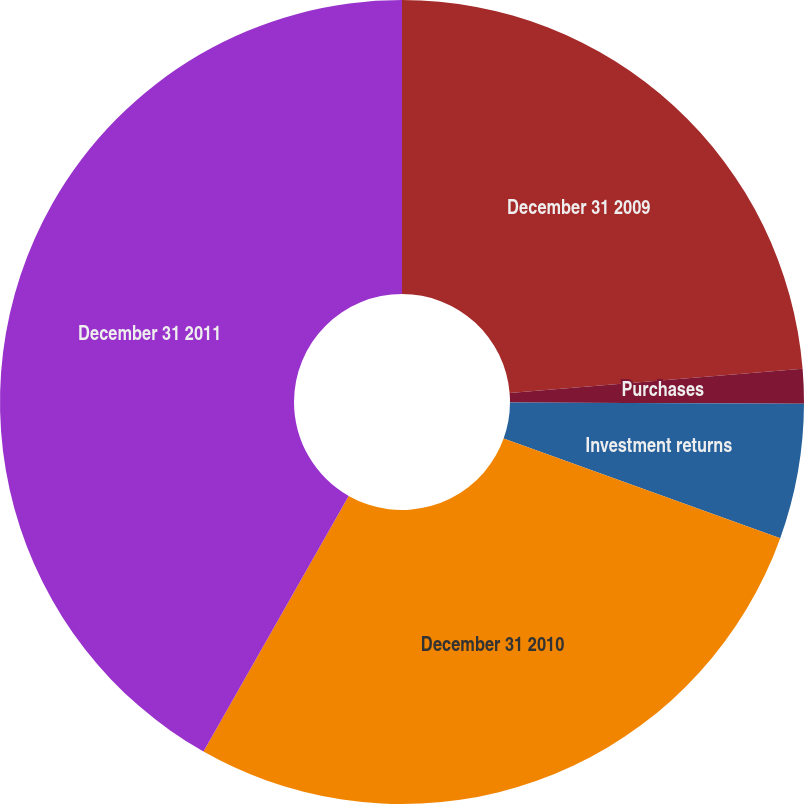Convert chart to OTSL. <chart><loc_0><loc_0><loc_500><loc_500><pie_chart><fcel>December 31 2009<fcel>Purchases<fcel>Investment returns<fcel>December 31 2010<fcel>December 31 2011<nl><fcel>23.68%<fcel>1.39%<fcel>5.43%<fcel>27.72%<fcel>41.78%<nl></chart> 